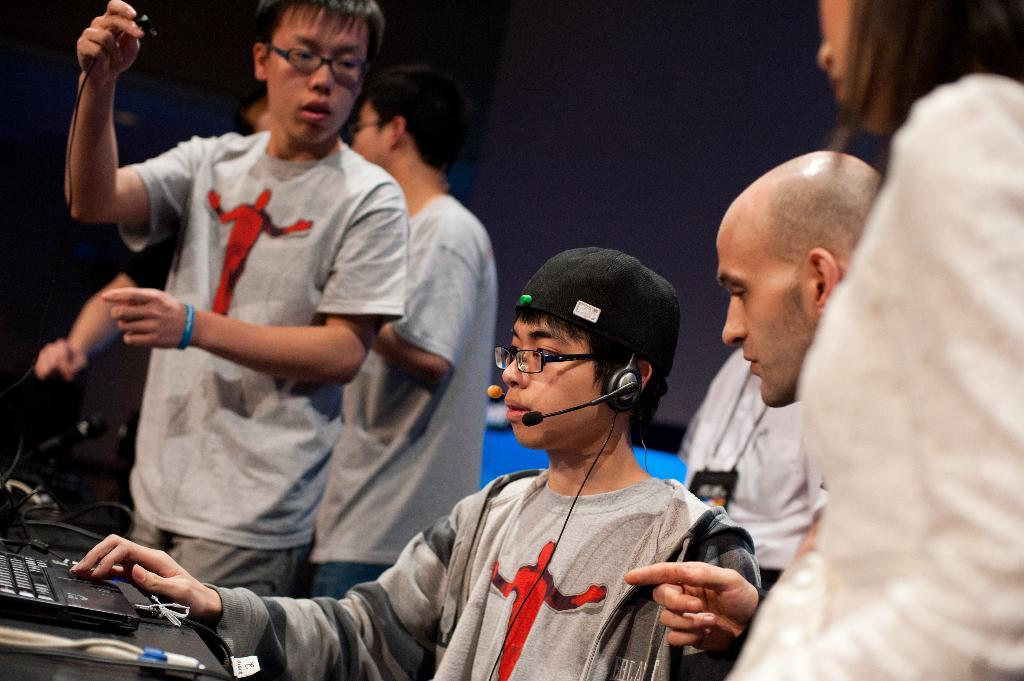How many people are in the image? There is a group of people in the image. What objects can be seen in the image that are related to sound? There are microphones in the image. What type of equipment is present in the image that connects devices? A: There are cables in the image. Can you describe the background of the image? The background of the image is blurry. What other objects can be seen in the image besides the people, microphones, and cables? There are some other objects in the image. What time of day is it in the image, and how does it affect the battle taking place? There is no battle present in the image, and the time of day cannot be determined from the provided facts. 